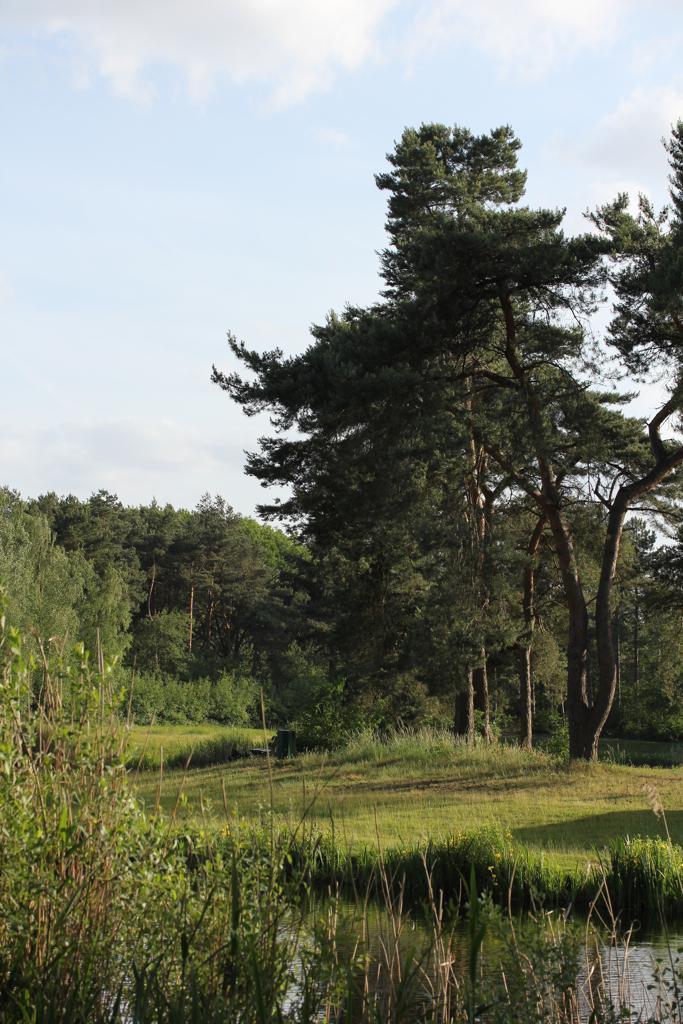Can you describe this image briefly? In this image I can see water, grass, shadows, number of trees, clouds and the sky. 